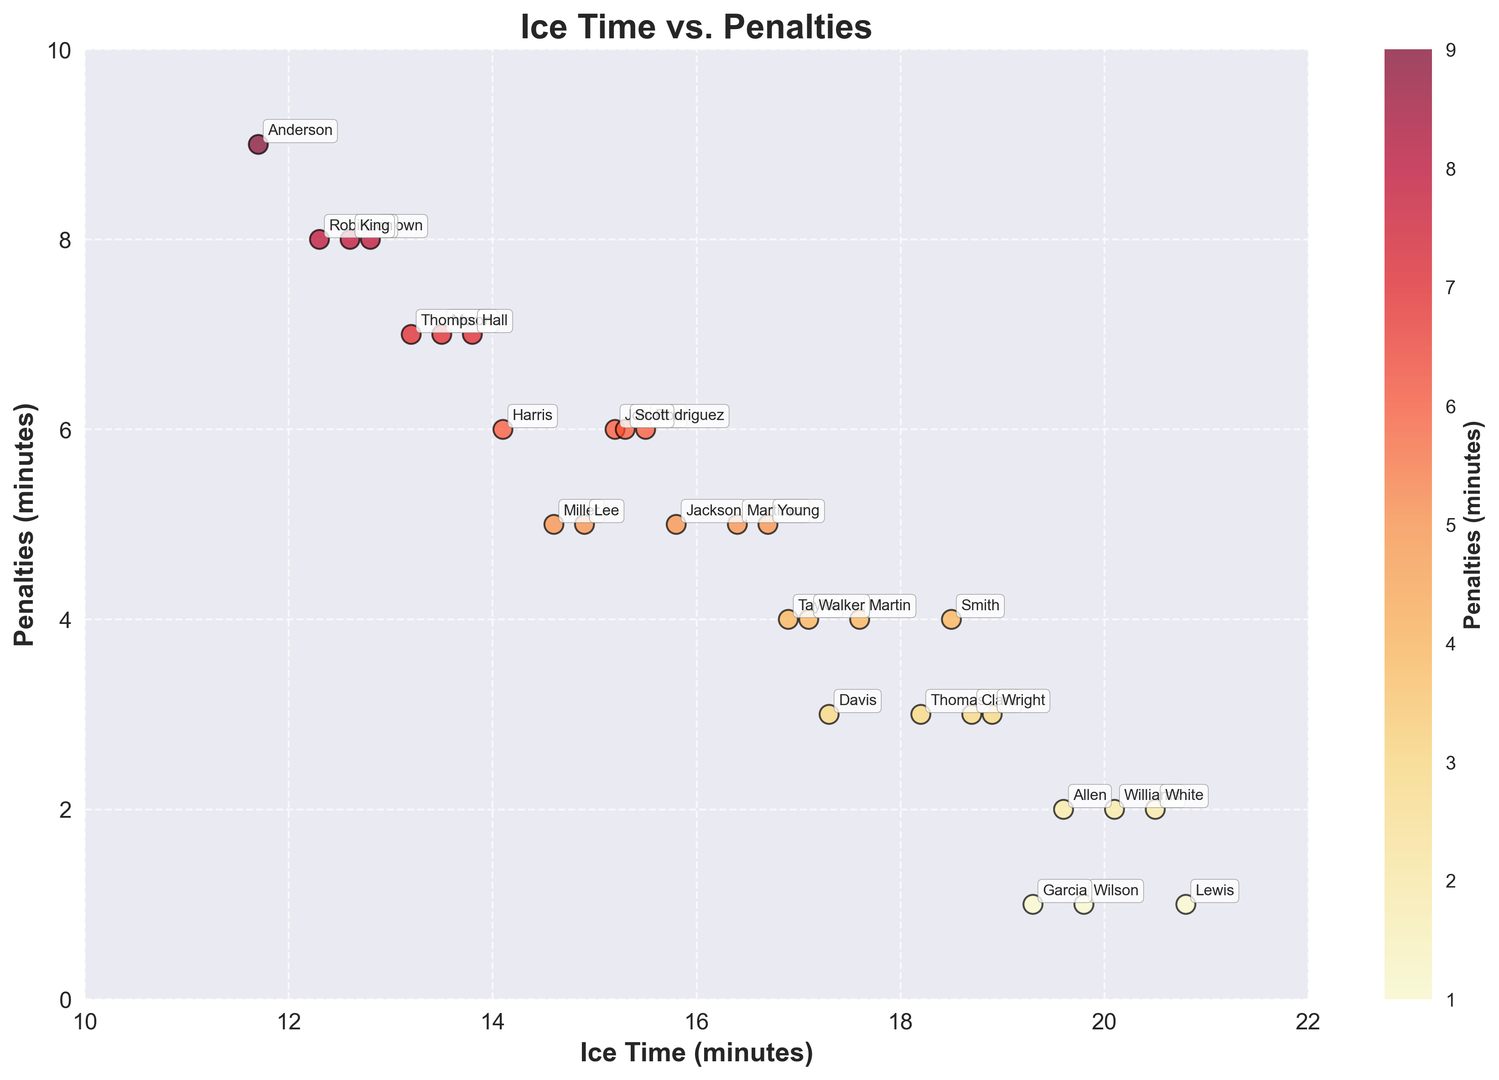Which player has the highest ice time and the lowest penalties? By examining the scatter plot, we find that the player with the highest ice time is Lewis with 20.8 minutes and the player with the lowest penalties is Lewis with 1 minute.
Answer: Lewis What is the difference in ice time between the player with the highest and the lowest penalties? The player with the highest penalties is Anderson with 9 minutes, and the player with the lowest penalties is Lewis with 1 minute. Their ice times are 11.7 minutes and 20.8 minutes respectively. The difference in ice time is 20.8 - 11.7 = 9.1 minutes.
Answer: 9.1 minutes Which player's ice time is closest to the average ice time across all players? To find the average ice time, sum up all the ice times and divide by the number of players. The total ice time is 460.4 minutes and there are 30 players. The average ice time is 460.4 / 30 = 15.35 minutes. Johnson's ice time of 15.2 minutes is closest to 15.35 minutes.
Answer: Johnson Which player with penalties greater than 5 minutes has the highest ice time? The scatter plot shows that players with penalties greater than 5 minutes are Johnson, Harris, Moore, Anderson, Thompson, Hall, Robinson, and King. Among them, Moore has the highest ice time of 13.5 minutes.
Answer: Moore Is there any correlation visible between ice time and penalties? By observing the scatter plot, there isn't a clear linear correlation visible between ice time and penalties. Players with various ice times have varying numbers of penalties.
Answer: No clear correlation Which player with the lowest ice time has penalties equal to or greater than 5 minutes? The player with the lowest ice time is Anderson with 11.7 minutes. Anderson has penalties equal to 9 minutes.
Answer: Anderson How many players have ice times greater than 18 minutes and penalties less than or equal to 3 minutes? By examining the scatter plot, the players are Williams, Wilson, White, and Garcia who meet the criteria. All of them fall in the category of ice time > 18 minutes and penalties ≤ 3 minutes.
Answer: 4 players Based on the scatter plot, does higher ice time generally equate to fewer penalties? By inspecting the overall trend in the scatter plot, it is not apparent that higher ice time consistently equates to fewer penalties. There are players with high ice times having both high and low penalties.
Answer: Not consistently 